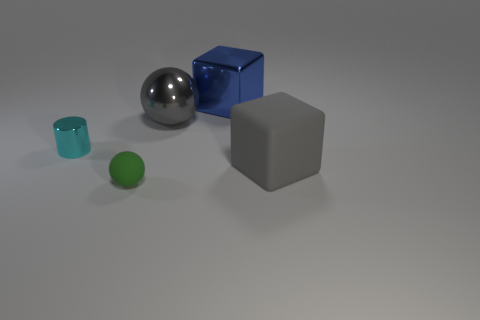Is there a large ball of the same color as the large rubber thing?
Offer a very short reply. Yes. Are there any matte objects that are behind the large metallic thing behind the metal sphere?
Give a very brief answer. No. Are there any gray things that have the same material as the blue thing?
Offer a very short reply. Yes. There is a gray object that is left of the blue thing that is behind the tiny green matte ball; what is it made of?
Provide a short and direct response. Metal. What material is the object that is both to the left of the large metallic cube and behind the small cyan thing?
Make the answer very short. Metal. Is the number of large things that are in front of the large blue metal thing the same as the number of small shiny cylinders?
Keep it short and to the point. No. How many other cyan things are the same shape as the small cyan metal object?
Make the answer very short. 0. What is the size of the sphere that is behind the rubber object to the left of the big gray object that is in front of the big ball?
Make the answer very short. Large. Is the material of the gray thing that is to the left of the metallic cube the same as the blue thing?
Your answer should be very brief. Yes. Is the number of tiny green rubber spheres on the right side of the gray metallic ball the same as the number of objects that are behind the gray rubber cube?
Your answer should be very brief. No. 